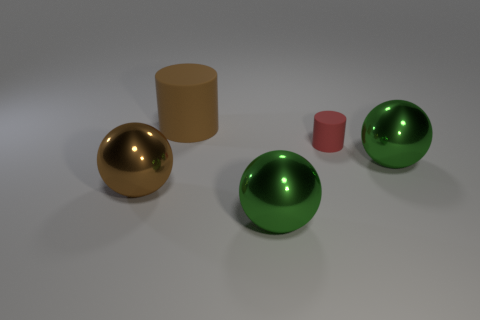How many other things are there of the same shape as the small matte thing?
Offer a terse response. 1. Is the number of big matte cylinders that are in front of the small rubber cylinder the same as the number of big blue metal objects?
Offer a very short reply. Yes. What is the shape of the large object that is on the right side of the brown matte object and on the left side of the tiny red rubber thing?
Provide a succinct answer. Sphere. Is the red rubber cylinder the same size as the brown cylinder?
Ensure brevity in your answer.  No. Is there a big green sphere that has the same material as the small red thing?
Offer a very short reply. No. What is the size of the sphere that is the same color as the big rubber object?
Provide a short and direct response. Large. How many objects are left of the small matte cylinder and in front of the red object?
Your answer should be very brief. 2. What material is the large brown object that is in front of the big cylinder?
Ensure brevity in your answer.  Metal. How many large metal spheres have the same color as the large rubber cylinder?
Give a very brief answer. 1. What is the size of the brown thing that is made of the same material as the small red cylinder?
Ensure brevity in your answer.  Large. 